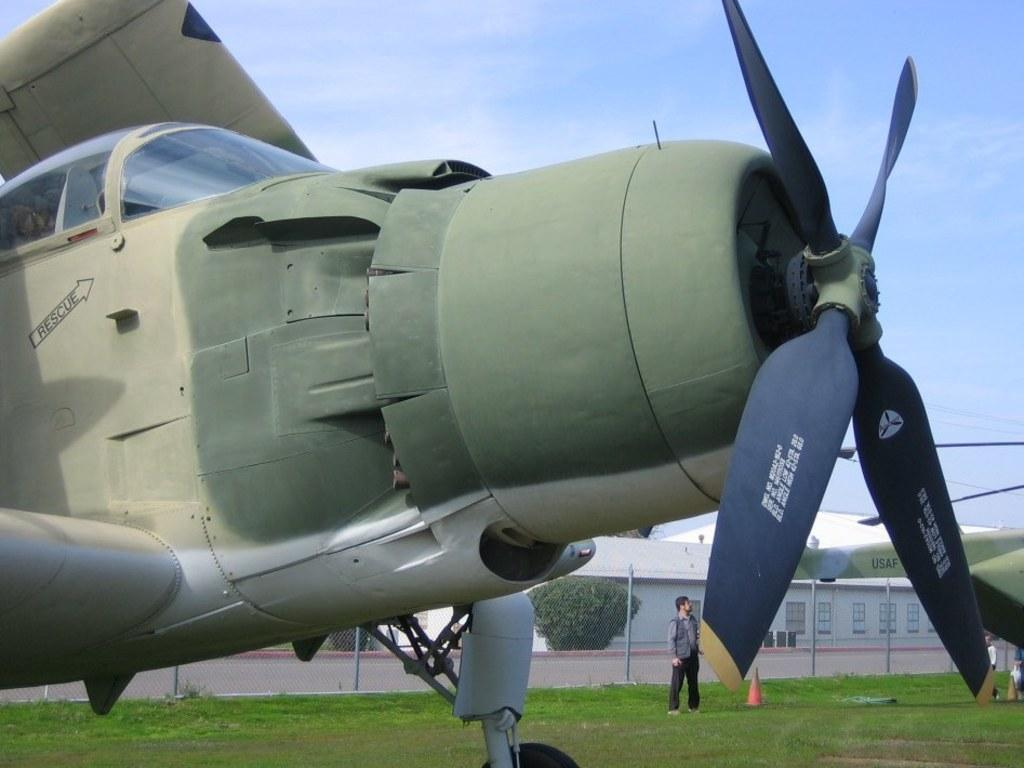Provide a one-sentence caption for the provided image. A plane has an arrow with the word rescue pointing to the pilots window. 